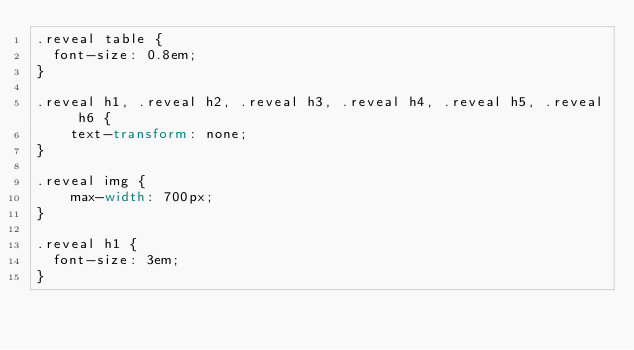Convert code to text. <code><loc_0><loc_0><loc_500><loc_500><_CSS_>.reveal table {
	font-size: 0.8em;
}

.reveal h1, .reveal h2, .reveal h3, .reveal h4, .reveal h5, .reveal h6 {
    text-transform: none;
}

.reveal img {
    max-width: 700px;
}

.reveal h1 {
	font-size: 3em;
}</code> 